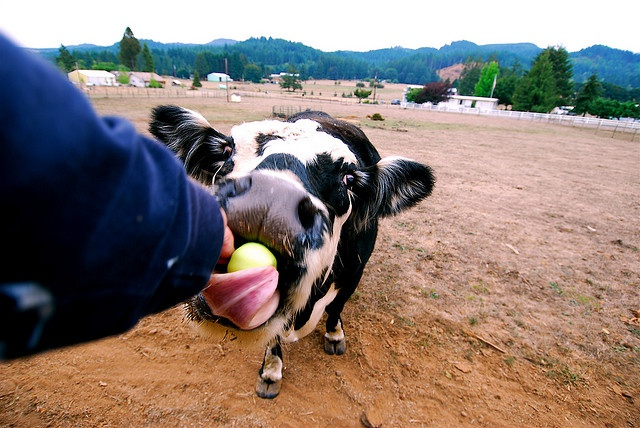Describe the objects in this image and their specific colors. I can see people in white, black, navy, and blue tones, cow in white, black, gray, and darkgray tones, and apple in white, ivory, khaki, and black tones in this image. 